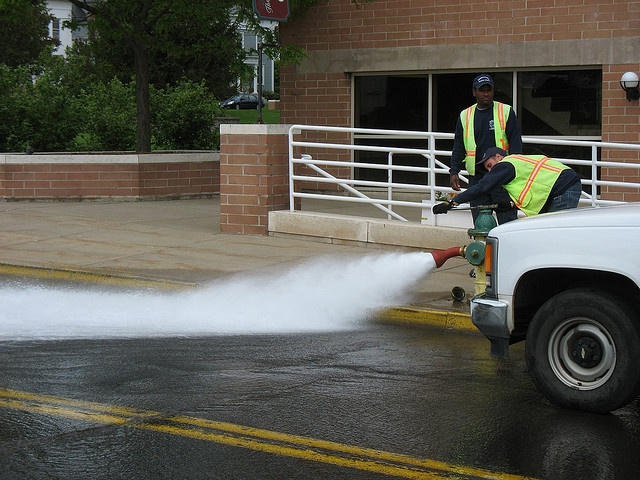Describe the objects in this image and their specific colors. I can see truck in darkgreen, black, lightgray, and gray tones, people in darkgreen, black, lightgreen, and khaki tones, people in darkgreen, black, and lightgreen tones, fire hydrant in darkgreen, teal, black, and olive tones, and car in darkgreen, black, purple, blue, and darkblue tones in this image. 